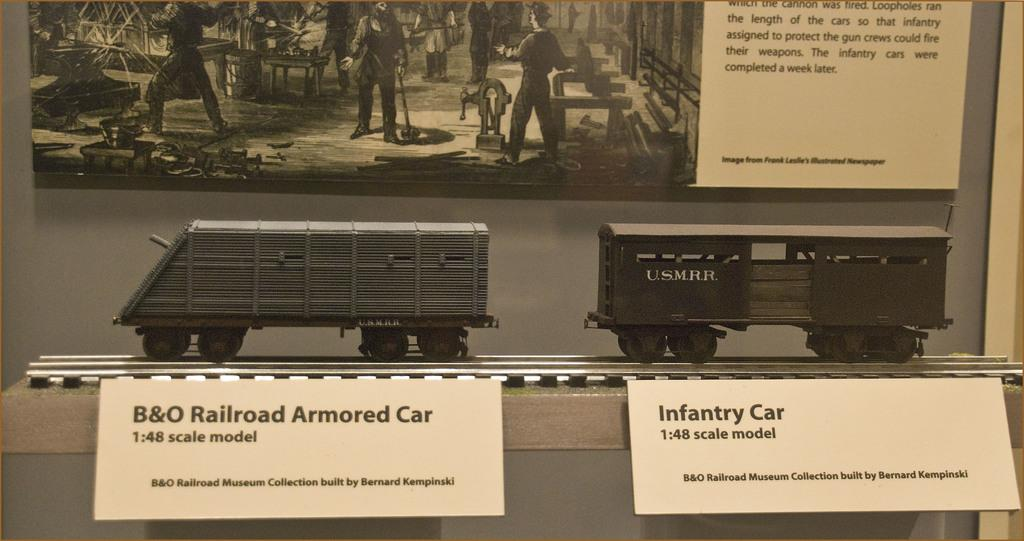What type of toy is present in the image? There are two toy trains in the image. What are the white colored objects in the image? There are two white colored boards in the image. What is the size of the largest board in the image? There is a huge board in the image. What can be seen in the photograph within the image? There is a photograph of a few persons standing in the image. Can you describe any other objects present in the image? There are other unspecified objects in the image. What type of weather is depicted in the image? There is no depiction of weather in the image; it features toy trains, boards, and a photograph of persons. What type of building is shown in the image? There is no building present in the image. 